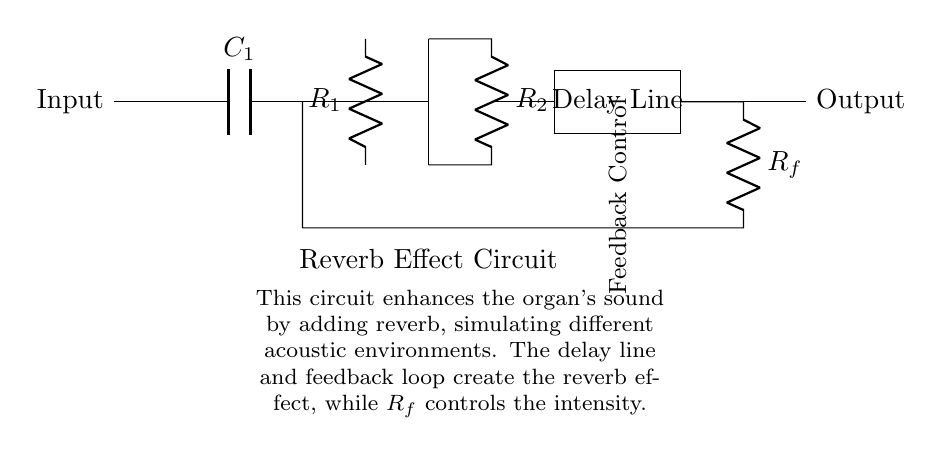What is the type of the main component in the circuit? The main component is an operational amplifier, indicated in the diagram. It typically amplifies the audio signal to create the desired reverb effect.
Answer: operational amplifier What does the feedback resistor control? The feedback resistor \( R_f \) controls the intensity of the reverb effect by adjusting the amount of feedback in the circuit. More feedback results in a stronger reverb, while less feedback decreases it.
Answer: intensity What function does the delay line serve? The delay line introduces a time delay to the signal, which is crucial for creating the reverb effect. This allows the sound to reflect and resonate as if in a larger acoustic space.
Answer: introduces time delay How many resistors are present in this circuit? There are two resistors in the circuit: \( R_1 \) and \( R_2 \), as labeled. These resistors can affect the gain and overall behavior of the operational amplifier.
Answer: two Which component connects directly to the input? The capacitor \( C_1 \) is the component that connects directly to the input. It helps in filtering the audio signal before it reaches the operational amplifier.
Answer: capacitor What is the purpose of the reverb effect in this circuit? The purpose of the reverb effect is to enhance the organ's sound, simulating various acoustic environments. It adds depth and a sense of space to the audio output, making it more pleasant and engaging.
Answer: enhance sound Where is the output located in the circuit? The output is located on the right side of the diagram, indicated by the label "Output." This is where the processed audio signal, with reverb applied, is sent out.
Answer: right side 